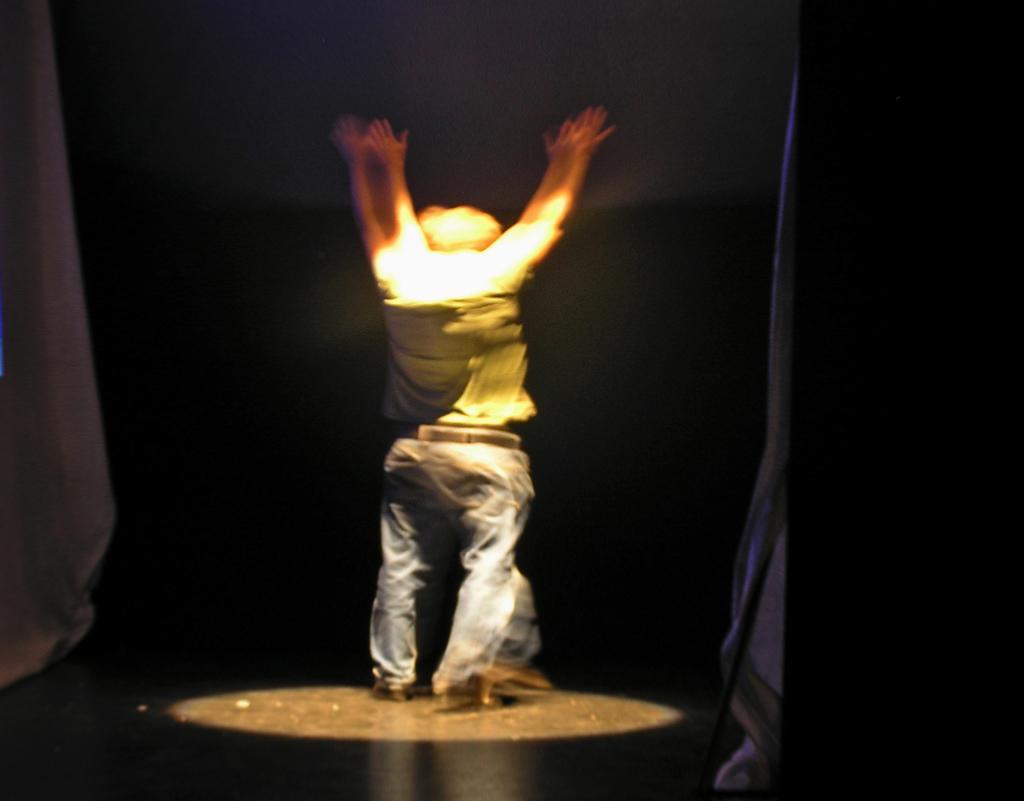How would you summarize this image in a sentence or two? A person is standing and raising his hands. There is spotlight on him. The background is black. 